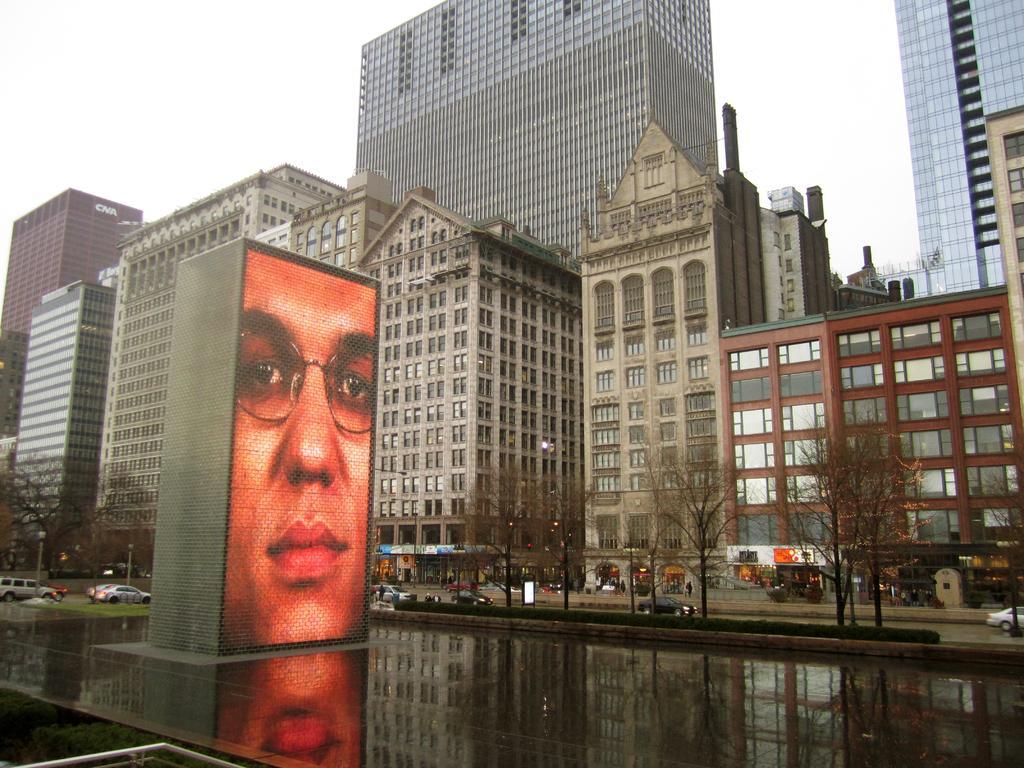Describe this image in one or two sentences. In this image there is a water surface in middle if water surface there is a fountain, in the background there are trees, cars on road, buildings and the sky. 